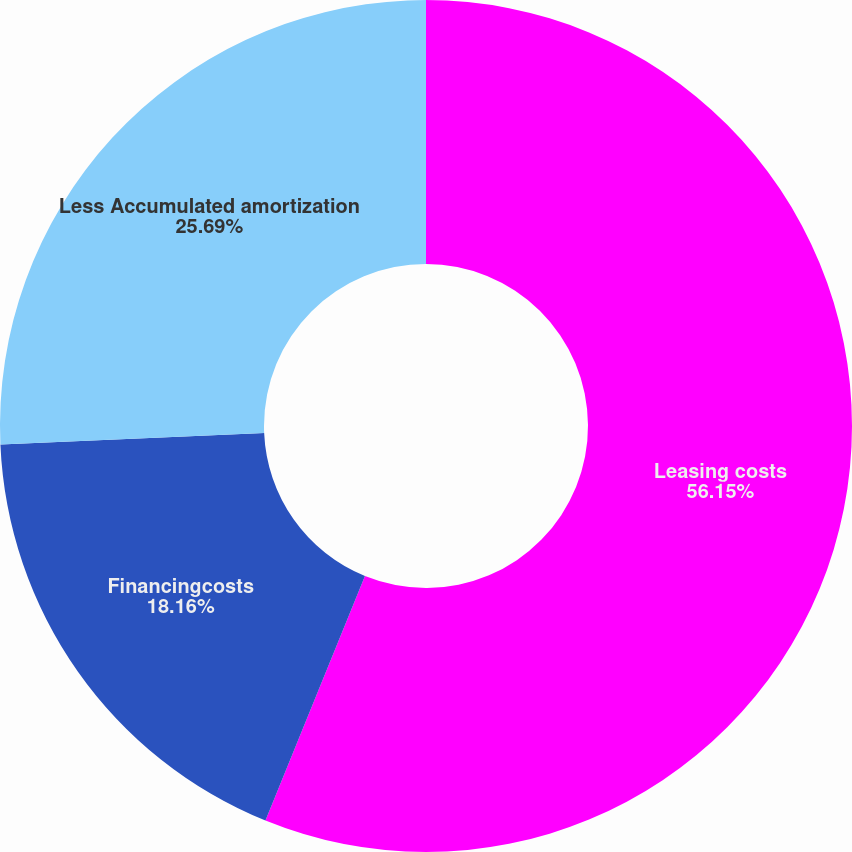<chart> <loc_0><loc_0><loc_500><loc_500><pie_chart><fcel>Leasing costs<fcel>Financingcosts<fcel>Less Accumulated amortization<nl><fcel>56.15%<fcel>18.16%<fcel>25.69%<nl></chart> 